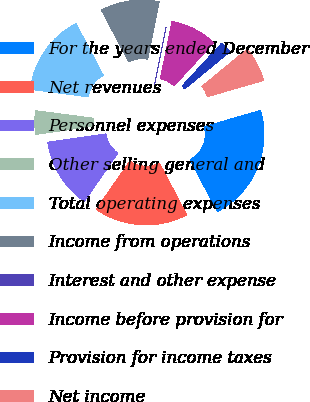Convert chart. <chart><loc_0><loc_0><loc_500><loc_500><pie_chart><fcel>For the years ended December<fcel>Net revenues<fcel>Personnel expenses<fcel>Other selling general and<fcel>Total operating expenses<fcel>Income from operations<fcel>Interest and other expense<fcel>Income before provision for<fcel>Provision for income taxes<fcel>Net income<nl><fcel>21.73%<fcel>17.39%<fcel>13.04%<fcel>4.35%<fcel>15.21%<fcel>10.87%<fcel>0.01%<fcel>8.7%<fcel>2.18%<fcel>6.52%<nl></chart> 